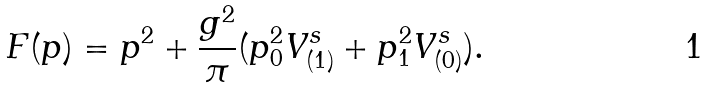<formula> <loc_0><loc_0><loc_500><loc_500>F ( p ) = p ^ { 2 } + \frac { g ^ { 2 } } { \pi } ( p _ { 0 } ^ { 2 } V _ { ( 1 ) } ^ { s } + p _ { 1 } ^ { 2 } V _ { ( 0 ) } ^ { s } ) .</formula> 